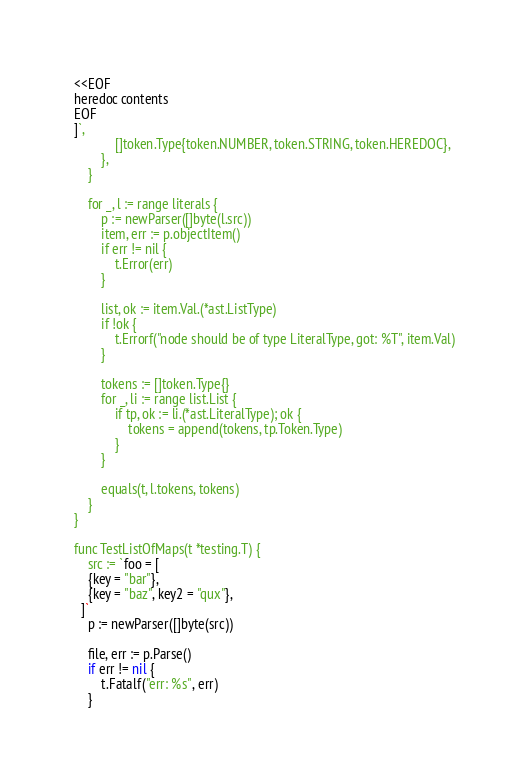Convert code to text. <code><loc_0><loc_0><loc_500><loc_500><_Go_><<EOF
heredoc contents
EOF
]`,
			[]token.Type{token.NUMBER, token.STRING, token.HEREDOC},
		},
	}

	for _, l := range literals {
		p := newParser([]byte(l.src))
		item, err := p.objectItem()
		if err != nil {
			t.Error(err)
		}

		list, ok := item.Val.(*ast.ListType)
		if !ok {
			t.Errorf("node should be of type LiteralType, got: %T", item.Val)
		}

		tokens := []token.Type{}
		for _, li := range list.List {
			if tp, ok := li.(*ast.LiteralType); ok {
				tokens = append(tokens, tp.Token.Type)
			}
		}

		equals(t, l.tokens, tokens)
	}
}

func TestListOfMaps(t *testing.T) {
	src := `foo = [
    {key = "bar"},
    {key = "baz", key2 = "qux"},
  ]`
	p := newParser([]byte(src))

	file, err := p.Parse()
	if err != nil {
		t.Fatalf("err: %s", err)
	}
</code> 